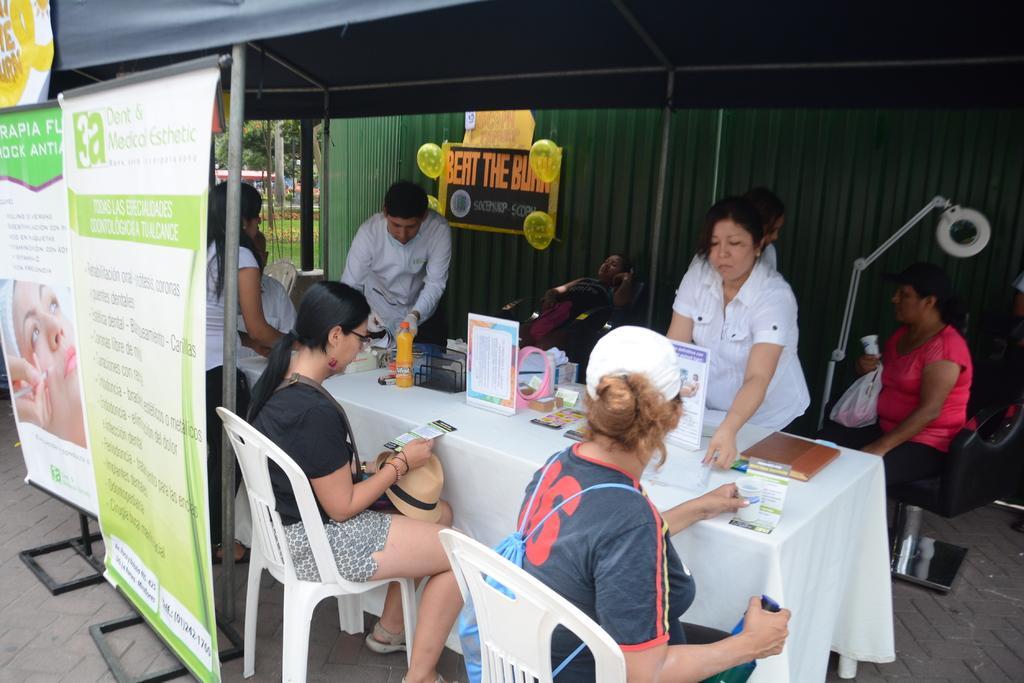Describe this image in one or two sentences. In this image, we can see persons wearing clothes. There are banners on the left side of the image. There is a tent at the top of the image. There is a container in the middle of the image. There are two persons at the bottom of the image sitting on chairs in front of the table. This table contains bottle, boards and some objects. There is a stand on the right side of the image. 